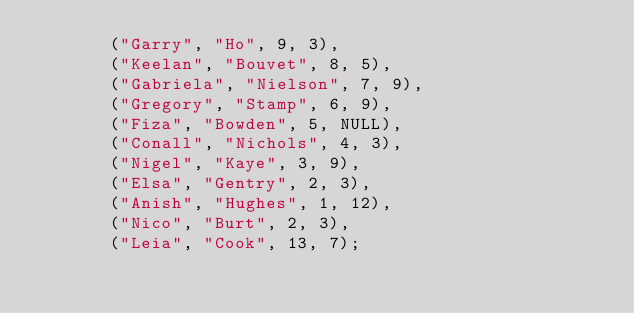Convert code to text. <code><loc_0><loc_0><loc_500><loc_500><_SQL_>       ("Garry", "Ho", 9, 3),  
       ("Keelan", "Bouvet", 8, 5),  
       ("Gabriela", "Nielson", 7, 9),  
       ("Gregory", "Stamp", 6, 9),  
       ("Fiza", "Bowden", 5, NULL),  
       ("Conall", "Nichols", 4, 3),  
       ("Nigel", "Kaye", 3, 9),  
       ("Elsa", "Gentry", 2, 3),  
       ("Anish", "Hughes", 1, 12),  
       ("Nico", "Burt", 2, 3),  
       ("Leia", "Cook", 13, 7);

       </code> 